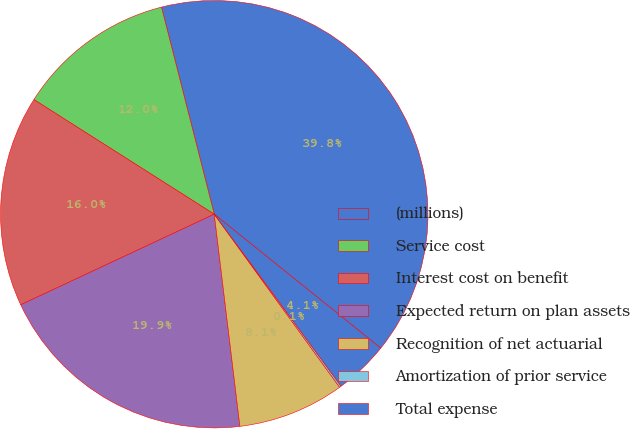Convert chart to OTSL. <chart><loc_0><loc_0><loc_500><loc_500><pie_chart><fcel>(millions)<fcel>Service cost<fcel>Interest cost on benefit<fcel>Expected return on plan assets<fcel>Recognition of net actuarial<fcel>Amortization of prior service<fcel>Total expense<nl><fcel>39.76%<fcel>12.02%<fcel>15.98%<fcel>19.95%<fcel>8.06%<fcel>0.14%<fcel>4.1%<nl></chart> 